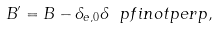Convert formula to latex. <formula><loc_0><loc_0><loc_500><loc_500>B ^ { \prime } = B - \delta _ { e , 0 } \delta \ p f i n o t p e r p ,</formula> 